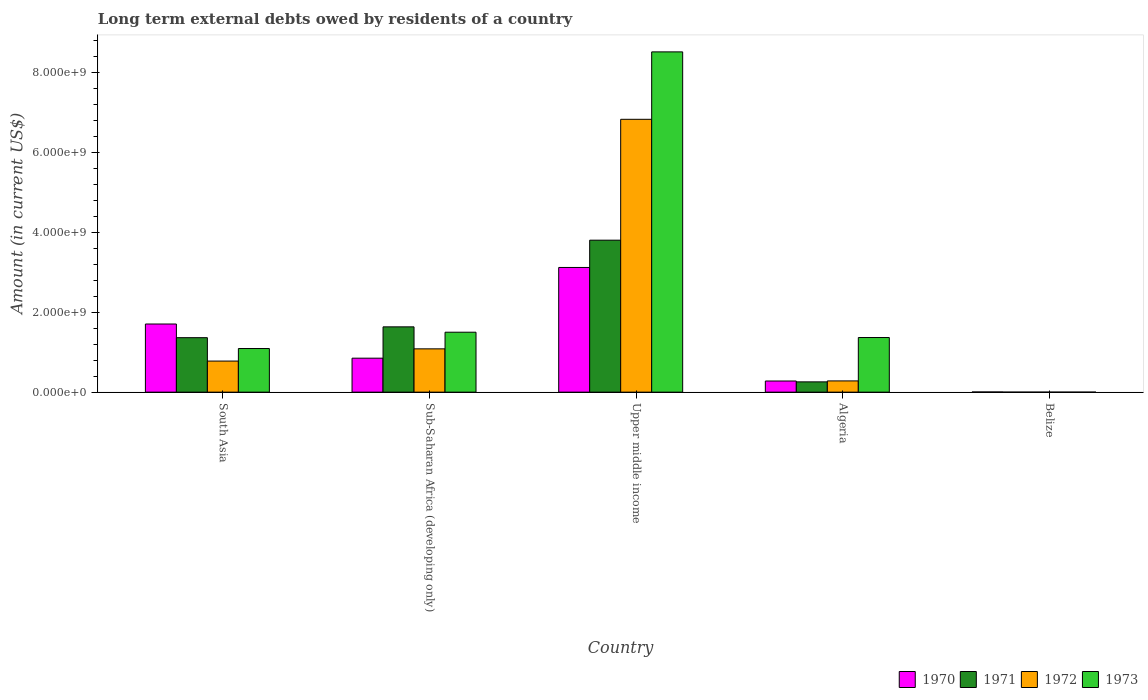How many different coloured bars are there?
Your response must be concise. 4. Are the number of bars per tick equal to the number of legend labels?
Your response must be concise. No. Are the number of bars on each tick of the X-axis equal?
Provide a succinct answer. No. How many bars are there on the 2nd tick from the left?
Your answer should be compact. 4. How many bars are there on the 5th tick from the right?
Provide a short and direct response. 4. What is the label of the 5th group of bars from the left?
Provide a succinct answer. Belize. In how many cases, is the number of bars for a given country not equal to the number of legend labels?
Your response must be concise. 1. What is the amount of long-term external debts owed by residents in 1970 in Upper middle income?
Offer a very short reply. 3.12e+09. Across all countries, what is the maximum amount of long-term external debts owed by residents in 1970?
Offer a very short reply. 3.12e+09. Across all countries, what is the minimum amount of long-term external debts owed by residents in 1970?
Offer a very short reply. 4.30e+06. In which country was the amount of long-term external debts owed by residents in 1970 maximum?
Your answer should be compact. Upper middle income. What is the total amount of long-term external debts owed by residents in 1970 in the graph?
Your answer should be compact. 5.96e+09. What is the difference between the amount of long-term external debts owed by residents in 1970 in Belize and that in South Asia?
Your response must be concise. -1.70e+09. What is the difference between the amount of long-term external debts owed by residents in 1973 in Upper middle income and the amount of long-term external debts owed by residents in 1971 in Algeria?
Provide a short and direct response. 8.25e+09. What is the average amount of long-term external debts owed by residents in 1970 per country?
Offer a very short reply. 1.19e+09. What is the difference between the amount of long-term external debts owed by residents of/in 1973 and amount of long-term external debts owed by residents of/in 1970 in South Asia?
Provide a succinct answer. -6.13e+08. What is the ratio of the amount of long-term external debts owed by residents in 1971 in Algeria to that in South Asia?
Offer a terse response. 0.19. Is the amount of long-term external debts owed by residents in 1970 in Belize less than that in South Asia?
Give a very brief answer. Yes. What is the difference between the highest and the second highest amount of long-term external debts owed by residents in 1970?
Make the answer very short. 1.41e+09. What is the difference between the highest and the lowest amount of long-term external debts owed by residents in 1970?
Your answer should be very brief. 3.11e+09. Is the sum of the amount of long-term external debts owed by residents in 1973 in South Asia and Sub-Saharan Africa (developing only) greater than the maximum amount of long-term external debts owed by residents in 1970 across all countries?
Give a very brief answer. No. Is it the case that in every country, the sum of the amount of long-term external debts owed by residents in 1971 and amount of long-term external debts owed by residents in 1970 is greater than the sum of amount of long-term external debts owed by residents in 1973 and amount of long-term external debts owed by residents in 1972?
Provide a short and direct response. No. Are all the bars in the graph horizontal?
Offer a very short reply. No. How many countries are there in the graph?
Offer a terse response. 5. Are the values on the major ticks of Y-axis written in scientific E-notation?
Make the answer very short. Yes. Where does the legend appear in the graph?
Make the answer very short. Bottom right. What is the title of the graph?
Ensure brevity in your answer.  Long term external debts owed by residents of a country. What is the Amount (in current US$) of 1970 in South Asia?
Make the answer very short. 1.70e+09. What is the Amount (in current US$) of 1971 in South Asia?
Offer a terse response. 1.36e+09. What is the Amount (in current US$) in 1972 in South Asia?
Your response must be concise. 7.77e+08. What is the Amount (in current US$) in 1973 in South Asia?
Ensure brevity in your answer.  1.09e+09. What is the Amount (in current US$) of 1970 in Sub-Saharan Africa (developing only)?
Ensure brevity in your answer.  8.50e+08. What is the Amount (in current US$) of 1971 in Sub-Saharan Africa (developing only)?
Make the answer very short. 1.63e+09. What is the Amount (in current US$) of 1972 in Sub-Saharan Africa (developing only)?
Keep it short and to the point. 1.08e+09. What is the Amount (in current US$) of 1973 in Sub-Saharan Africa (developing only)?
Provide a succinct answer. 1.50e+09. What is the Amount (in current US$) in 1970 in Upper middle income?
Your answer should be very brief. 3.12e+09. What is the Amount (in current US$) in 1971 in Upper middle income?
Ensure brevity in your answer.  3.80e+09. What is the Amount (in current US$) in 1972 in Upper middle income?
Ensure brevity in your answer.  6.82e+09. What is the Amount (in current US$) of 1973 in Upper middle income?
Your response must be concise. 8.51e+09. What is the Amount (in current US$) of 1970 in Algeria?
Provide a succinct answer. 2.79e+08. What is the Amount (in current US$) of 1971 in Algeria?
Your response must be concise. 2.57e+08. What is the Amount (in current US$) in 1972 in Algeria?
Your response must be concise. 2.81e+08. What is the Amount (in current US$) of 1973 in Algeria?
Your answer should be very brief. 1.37e+09. What is the Amount (in current US$) in 1970 in Belize?
Ensure brevity in your answer.  4.30e+06. What is the Amount (in current US$) in 1971 in Belize?
Provide a short and direct response. 0. What is the Amount (in current US$) in 1972 in Belize?
Offer a very short reply. 0. Across all countries, what is the maximum Amount (in current US$) in 1970?
Offer a very short reply. 3.12e+09. Across all countries, what is the maximum Amount (in current US$) in 1971?
Keep it short and to the point. 3.80e+09. Across all countries, what is the maximum Amount (in current US$) of 1972?
Ensure brevity in your answer.  6.82e+09. Across all countries, what is the maximum Amount (in current US$) in 1973?
Your answer should be compact. 8.51e+09. Across all countries, what is the minimum Amount (in current US$) of 1970?
Offer a very short reply. 4.30e+06. Across all countries, what is the minimum Amount (in current US$) in 1971?
Provide a succinct answer. 0. Across all countries, what is the minimum Amount (in current US$) of 1972?
Ensure brevity in your answer.  0. What is the total Amount (in current US$) in 1970 in the graph?
Ensure brevity in your answer.  5.96e+09. What is the total Amount (in current US$) of 1971 in the graph?
Provide a succinct answer. 7.05e+09. What is the total Amount (in current US$) in 1972 in the graph?
Your answer should be very brief. 8.97e+09. What is the total Amount (in current US$) of 1973 in the graph?
Provide a succinct answer. 1.25e+1. What is the difference between the Amount (in current US$) of 1970 in South Asia and that in Sub-Saharan Africa (developing only)?
Keep it short and to the point. 8.55e+08. What is the difference between the Amount (in current US$) in 1971 in South Asia and that in Sub-Saharan Africa (developing only)?
Offer a very short reply. -2.71e+08. What is the difference between the Amount (in current US$) of 1972 in South Asia and that in Sub-Saharan Africa (developing only)?
Offer a very short reply. -3.06e+08. What is the difference between the Amount (in current US$) of 1973 in South Asia and that in Sub-Saharan Africa (developing only)?
Your answer should be very brief. -4.08e+08. What is the difference between the Amount (in current US$) of 1970 in South Asia and that in Upper middle income?
Your answer should be very brief. -1.41e+09. What is the difference between the Amount (in current US$) of 1971 in South Asia and that in Upper middle income?
Offer a very short reply. -2.44e+09. What is the difference between the Amount (in current US$) in 1972 in South Asia and that in Upper middle income?
Ensure brevity in your answer.  -6.05e+09. What is the difference between the Amount (in current US$) of 1973 in South Asia and that in Upper middle income?
Provide a short and direct response. -7.42e+09. What is the difference between the Amount (in current US$) of 1970 in South Asia and that in Algeria?
Your answer should be very brief. 1.43e+09. What is the difference between the Amount (in current US$) of 1971 in South Asia and that in Algeria?
Provide a short and direct response. 1.11e+09. What is the difference between the Amount (in current US$) in 1972 in South Asia and that in Algeria?
Make the answer very short. 4.96e+08. What is the difference between the Amount (in current US$) in 1973 in South Asia and that in Algeria?
Ensure brevity in your answer.  -2.75e+08. What is the difference between the Amount (in current US$) in 1970 in South Asia and that in Belize?
Make the answer very short. 1.70e+09. What is the difference between the Amount (in current US$) of 1970 in Sub-Saharan Africa (developing only) and that in Upper middle income?
Provide a succinct answer. -2.27e+09. What is the difference between the Amount (in current US$) in 1971 in Sub-Saharan Africa (developing only) and that in Upper middle income?
Give a very brief answer. -2.17e+09. What is the difference between the Amount (in current US$) of 1972 in Sub-Saharan Africa (developing only) and that in Upper middle income?
Your answer should be compact. -5.74e+09. What is the difference between the Amount (in current US$) in 1973 in Sub-Saharan Africa (developing only) and that in Upper middle income?
Offer a terse response. -7.01e+09. What is the difference between the Amount (in current US$) in 1970 in Sub-Saharan Africa (developing only) and that in Algeria?
Keep it short and to the point. 5.71e+08. What is the difference between the Amount (in current US$) of 1971 in Sub-Saharan Africa (developing only) and that in Algeria?
Offer a very short reply. 1.38e+09. What is the difference between the Amount (in current US$) of 1972 in Sub-Saharan Africa (developing only) and that in Algeria?
Make the answer very short. 8.02e+08. What is the difference between the Amount (in current US$) of 1973 in Sub-Saharan Africa (developing only) and that in Algeria?
Ensure brevity in your answer.  1.33e+08. What is the difference between the Amount (in current US$) of 1970 in Sub-Saharan Africa (developing only) and that in Belize?
Provide a short and direct response. 8.45e+08. What is the difference between the Amount (in current US$) in 1970 in Upper middle income and that in Algeria?
Make the answer very short. 2.84e+09. What is the difference between the Amount (in current US$) of 1971 in Upper middle income and that in Algeria?
Ensure brevity in your answer.  3.54e+09. What is the difference between the Amount (in current US$) in 1972 in Upper middle income and that in Algeria?
Offer a terse response. 6.54e+09. What is the difference between the Amount (in current US$) in 1973 in Upper middle income and that in Algeria?
Ensure brevity in your answer.  7.14e+09. What is the difference between the Amount (in current US$) in 1970 in Upper middle income and that in Belize?
Make the answer very short. 3.11e+09. What is the difference between the Amount (in current US$) of 1970 in Algeria and that in Belize?
Ensure brevity in your answer.  2.74e+08. What is the difference between the Amount (in current US$) in 1970 in South Asia and the Amount (in current US$) in 1971 in Sub-Saharan Africa (developing only)?
Provide a short and direct response. 7.12e+07. What is the difference between the Amount (in current US$) of 1970 in South Asia and the Amount (in current US$) of 1972 in Sub-Saharan Africa (developing only)?
Provide a succinct answer. 6.21e+08. What is the difference between the Amount (in current US$) of 1970 in South Asia and the Amount (in current US$) of 1973 in Sub-Saharan Africa (developing only)?
Your answer should be very brief. 2.05e+08. What is the difference between the Amount (in current US$) in 1971 in South Asia and the Amount (in current US$) in 1972 in Sub-Saharan Africa (developing only)?
Keep it short and to the point. 2.80e+08. What is the difference between the Amount (in current US$) of 1971 in South Asia and the Amount (in current US$) of 1973 in Sub-Saharan Africa (developing only)?
Keep it short and to the point. -1.37e+08. What is the difference between the Amount (in current US$) of 1972 in South Asia and the Amount (in current US$) of 1973 in Sub-Saharan Africa (developing only)?
Provide a short and direct response. -7.22e+08. What is the difference between the Amount (in current US$) in 1970 in South Asia and the Amount (in current US$) in 1971 in Upper middle income?
Provide a short and direct response. -2.10e+09. What is the difference between the Amount (in current US$) in 1970 in South Asia and the Amount (in current US$) in 1972 in Upper middle income?
Offer a very short reply. -5.12e+09. What is the difference between the Amount (in current US$) of 1970 in South Asia and the Amount (in current US$) of 1973 in Upper middle income?
Your answer should be very brief. -6.81e+09. What is the difference between the Amount (in current US$) in 1971 in South Asia and the Amount (in current US$) in 1972 in Upper middle income?
Offer a terse response. -5.46e+09. What is the difference between the Amount (in current US$) in 1971 in South Asia and the Amount (in current US$) in 1973 in Upper middle income?
Your answer should be compact. -7.15e+09. What is the difference between the Amount (in current US$) in 1972 in South Asia and the Amount (in current US$) in 1973 in Upper middle income?
Offer a very short reply. -7.73e+09. What is the difference between the Amount (in current US$) in 1970 in South Asia and the Amount (in current US$) in 1971 in Algeria?
Your answer should be compact. 1.45e+09. What is the difference between the Amount (in current US$) of 1970 in South Asia and the Amount (in current US$) of 1972 in Algeria?
Offer a very short reply. 1.42e+09. What is the difference between the Amount (in current US$) of 1970 in South Asia and the Amount (in current US$) of 1973 in Algeria?
Ensure brevity in your answer.  3.38e+08. What is the difference between the Amount (in current US$) of 1971 in South Asia and the Amount (in current US$) of 1972 in Algeria?
Provide a succinct answer. 1.08e+09. What is the difference between the Amount (in current US$) of 1971 in South Asia and the Amount (in current US$) of 1973 in Algeria?
Your response must be concise. -3.79e+06. What is the difference between the Amount (in current US$) in 1972 in South Asia and the Amount (in current US$) in 1973 in Algeria?
Your answer should be compact. -5.89e+08. What is the difference between the Amount (in current US$) of 1970 in Sub-Saharan Africa (developing only) and the Amount (in current US$) of 1971 in Upper middle income?
Offer a terse response. -2.95e+09. What is the difference between the Amount (in current US$) of 1970 in Sub-Saharan Africa (developing only) and the Amount (in current US$) of 1972 in Upper middle income?
Keep it short and to the point. -5.97e+09. What is the difference between the Amount (in current US$) in 1970 in Sub-Saharan Africa (developing only) and the Amount (in current US$) in 1973 in Upper middle income?
Make the answer very short. -7.66e+09. What is the difference between the Amount (in current US$) of 1971 in Sub-Saharan Africa (developing only) and the Amount (in current US$) of 1972 in Upper middle income?
Your response must be concise. -5.19e+09. What is the difference between the Amount (in current US$) of 1971 in Sub-Saharan Africa (developing only) and the Amount (in current US$) of 1973 in Upper middle income?
Your response must be concise. -6.88e+09. What is the difference between the Amount (in current US$) in 1972 in Sub-Saharan Africa (developing only) and the Amount (in current US$) in 1973 in Upper middle income?
Give a very brief answer. -7.43e+09. What is the difference between the Amount (in current US$) in 1970 in Sub-Saharan Africa (developing only) and the Amount (in current US$) in 1971 in Algeria?
Provide a short and direct response. 5.93e+08. What is the difference between the Amount (in current US$) in 1970 in Sub-Saharan Africa (developing only) and the Amount (in current US$) in 1972 in Algeria?
Offer a very short reply. 5.69e+08. What is the difference between the Amount (in current US$) of 1970 in Sub-Saharan Africa (developing only) and the Amount (in current US$) of 1973 in Algeria?
Make the answer very short. -5.17e+08. What is the difference between the Amount (in current US$) in 1971 in Sub-Saharan Africa (developing only) and the Amount (in current US$) in 1972 in Algeria?
Your answer should be compact. 1.35e+09. What is the difference between the Amount (in current US$) in 1971 in Sub-Saharan Africa (developing only) and the Amount (in current US$) in 1973 in Algeria?
Offer a terse response. 2.67e+08. What is the difference between the Amount (in current US$) of 1972 in Sub-Saharan Africa (developing only) and the Amount (in current US$) of 1973 in Algeria?
Provide a short and direct response. -2.83e+08. What is the difference between the Amount (in current US$) in 1970 in Upper middle income and the Amount (in current US$) in 1971 in Algeria?
Your response must be concise. 2.86e+09. What is the difference between the Amount (in current US$) in 1970 in Upper middle income and the Amount (in current US$) in 1972 in Algeria?
Offer a terse response. 2.84e+09. What is the difference between the Amount (in current US$) of 1970 in Upper middle income and the Amount (in current US$) of 1973 in Algeria?
Give a very brief answer. 1.75e+09. What is the difference between the Amount (in current US$) of 1971 in Upper middle income and the Amount (in current US$) of 1972 in Algeria?
Offer a terse response. 3.52e+09. What is the difference between the Amount (in current US$) of 1971 in Upper middle income and the Amount (in current US$) of 1973 in Algeria?
Ensure brevity in your answer.  2.43e+09. What is the difference between the Amount (in current US$) of 1972 in Upper middle income and the Amount (in current US$) of 1973 in Algeria?
Offer a very short reply. 5.46e+09. What is the average Amount (in current US$) of 1970 per country?
Provide a short and direct response. 1.19e+09. What is the average Amount (in current US$) of 1971 per country?
Your answer should be very brief. 1.41e+09. What is the average Amount (in current US$) of 1972 per country?
Ensure brevity in your answer.  1.79e+09. What is the average Amount (in current US$) of 1973 per country?
Offer a terse response. 2.49e+09. What is the difference between the Amount (in current US$) of 1970 and Amount (in current US$) of 1971 in South Asia?
Give a very brief answer. 3.42e+08. What is the difference between the Amount (in current US$) of 1970 and Amount (in current US$) of 1972 in South Asia?
Your answer should be compact. 9.27e+08. What is the difference between the Amount (in current US$) in 1970 and Amount (in current US$) in 1973 in South Asia?
Offer a very short reply. 6.13e+08. What is the difference between the Amount (in current US$) in 1971 and Amount (in current US$) in 1972 in South Asia?
Offer a terse response. 5.85e+08. What is the difference between the Amount (in current US$) in 1971 and Amount (in current US$) in 1973 in South Asia?
Provide a short and direct response. 2.72e+08. What is the difference between the Amount (in current US$) in 1972 and Amount (in current US$) in 1973 in South Asia?
Provide a short and direct response. -3.14e+08. What is the difference between the Amount (in current US$) of 1970 and Amount (in current US$) of 1971 in Sub-Saharan Africa (developing only)?
Your answer should be very brief. -7.84e+08. What is the difference between the Amount (in current US$) in 1970 and Amount (in current US$) in 1972 in Sub-Saharan Africa (developing only)?
Your response must be concise. -2.33e+08. What is the difference between the Amount (in current US$) of 1970 and Amount (in current US$) of 1973 in Sub-Saharan Africa (developing only)?
Ensure brevity in your answer.  -6.50e+08. What is the difference between the Amount (in current US$) in 1971 and Amount (in current US$) in 1972 in Sub-Saharan Africa (developing only)?
Offer a very short reply. 5.50e+08. What is the difference between the Amount (in current US$) in 1971 and Amount (in current US$) in 1973 in Sub-Saharan Africa (developing only)?
Your answer should be very brief. 1.34e+08. What is the difference between the Amount (in current US$) in 1972 and Amount (in current US$) in 1973 in Sub-Saharan Africa (developing only)?
Provide a short and direct response. -4.16e+08. What is the difference between the Amount (in current US$) in 1970 and Amount (in current US$) in 1971 in Upper middle income?
Give a very brief answer. -6.83e+08. What is the difference between the Amount (in current US$) in 1970 and Amount (in current US$) in 1972 in Upper middle income?
Provide a succinct answer. -3.71e+09. What is the difference between the Amount (in current US$) in 1970 and Amount (in current US$) in 1973 in Upper middle income?
Keep it short and to the point. -5.39e+09. What is the difference between the Amount (in current US$) of 1971 and Amount (in current US$) of 1972 in Upper middle income?
Provide a short and direct response. -3.02e+09. What is the difference between the Amount (in current US$) of 1971 and Amount (in current US$) of 1973 in Upper middle income?
Ensure brevity in your answer.  -4.71e+09. What is the difference between the Amount (in current US$) of 1972 and Amount (in current US$) of 1973 in Upper middle income?
Ensure brevity in your answer.  -1.69e+09. What is the difference between the Amount (in current US$) in 1970 and Amount (in current US$) in 1971 in Algeria?
Ensure brevity in your answer.  2.18e+07. What is the difference between the Amount (in current US$) in 1970 and Amount (in current US$) in 1972 in Algeria?
Provide a short and direct response. -2.27e+06. What is the difference between the Amount (in current US$) in 1970 and Amount (in current US$) in 1973 in Algeria?
Provide a succinct answer. -1.09e+09. What is the difference between the Amount (in current US$) of 1971 and Amount (in current US$) of 1972 in Algeria?
Offer a terse response. -2.41e+07. What is the difference between the Amount (in current US$) in 1971 and Amount (in current US$) in 1973 in Algeria?
Offer a very short reply. -1.11e+09. What is the difference between the Amount (in current US$) in 1972 and Amount (in current US$) in 1973 in Algeria?
Offer a very short reply. -1.09e+09. What is the ratio of the Amount (in current US$) in 1970 in South Asia to that in Sub-Saharan Africa (developing only)?
Make the answer very short. 2.01. What is the ratio of the Amount (in current US$) in 1971 in South Asia to that in Sub-Saharan Africa (developing only)?
Give a very brief answer. 0.83. What is the ratio of the Amount (in current US$) of 1972 in South Asia to that in Sub-Saharan Africa (developing only)?
Keep it short and to the point. 0.72. What is the ratio of the Amount (in current US$) of 1973 in South Asia to that in Sub-Saharan Africa (developing only)?
Your answer should be compact. 0.73. What is the ratio of the Amount (in current US$) in 1970 in South Asia to that in Upper middle income?
Offer a very short reply. 0.55. What is the ratio of the Amount (in current US$) of 1971 in South Asia to that in Upper middle income?
Give a very brief answer. 0.36. What is the ratio of the Amount (in current US$) of 1972 in South Asia to that in Upper middle income?
Keep it short and to the point. 0.11. What is the ratio of the Amount (in current US$) in 1973 in South Asia to that in Upper middle income?
Offer a terse response. 0.13. What is the ratio of the Amount (in current US$) of 1970 in South Asia to that in Algeria?
Offer a very short reply. 6.11. What is the ratio of the Amount (in current US$) of 1971 in South Asia to that in Algeria?
Offer a very short reply. 5.3. What is the ratio of the Amount (in current US$) of 1972 in South Asia to that in Algeria?
Keep it short and to the point. 2.77. What is the ratio of the Amount (in current US$) in 1973 in South Asia to that in Algeria?
Your response must be concise. 0.8. What is the ratio of the Amount (in current US$) in 1970 in South Asia to that in Belize?
Keep it short and to the point. 396.27. What is the ratio of the Amount (in current US$) of 1970 in Sub-Saharan Africa (developing only) to that in Upper middle income?
Make the answer very short. 0.27. What is the ratio of the Amount (in current US$) of 1971 in Sub-Saharan Africa (developing only) to that in Upper middle income?
Provide a succinct answer. 0.43. What is the ratio of the Amount (in current US$) in 1972 in Sub-Saharan Africa (developing only) to that in Upper middle income?
Offer a terse response. 0.16. What is the ratio of the Amount (in current US$) of 1973 in Sub-Saharan Africa (developing only) to that in Upper middle income?
Offer a very short reply. 0.18. What is the ratio of the Amount (in current US$) in 1970 in Sub-Saharan Africa (developing only) to that in Algeria?
Give a very brief answer. 3.05. What is the ratio of the Amount (in current US$) of 1971 in Sub-Saharan Africa (developing only) to that in Algeria?
Keep it short and to the point. 6.35. What is the ratio of the Amount (in current US$) of 1972 in Sub-Saharan Africa (developing only) to that in Algeria?
Offer a terse response. 3.85. What is the ratio of the Amount (in current US$) in 1973 in Sub-Saharan Africa (developing only) to that in Algeria?
Offer a very short reply. 1.1. What is the ratio of the Amount (in current US$) in 1970 in Sub-Saharan Africa (developing only) to that in Belize?
Your response must be concise. 197.54. What is the ratio of the Amount (in current US$) in 1970 in Upper middle income to that in Algeria?
Offer a terse response. 11.19. What is the ratio of the Amount (in current US$) of 1971 in Upper middle income to that in Algeria?
Keep it short and to the point. 14.79. What is the ratio of the Amount (in current US$) in 1972 in Upper middle income to that in Algeria?
Your answer should be very brief. 24.28. What is the ratio of the Amount (in current US$) of 1973 in Upper middle income to that in Algeria?
Give a very brief answer. 6.23. What is the ratio of the Amount (in current US$) of 1970 in Upper middle income to that in Belize?
Your answer should be very brief. 725.1. What is the ratio of the Amount (in current US$) in 1970 in Algeria to that in Belize?
Give a very brief answer. 64.82. What is the difference between the highest and the second highest Amount (in current US$) of 1970?
Ensure brevity in your answer.  1.41e+09. What is the difference between the highest and the second highest Amount (in current US$) of 1971?
Your answer should be compact. 2.17e+09. What is the difference between the highest and the second highest Amount (in current US$) of 1972?
Make the answer very short. 5.74e+09. What is the difference between the highest and the second highest Amount (in current US$) in 1973?
Offer a very short reply. 7.01e+09. What is the difference between the highest and the lowest Amount (in current US$) in 1970?
Your answer should be compact. 3.11e+09. What is the difference between the highest and the lowest Amount (in current US$) of 1971?
Offer a terse response. 3.80e+09. What is the difference between the highest and the lowest Amount (in current US$) of 1972?
Your response must be concise. 6.82e+09. What is the difference between the highest and the lowest Amount (in current US$) of 1973?
Your response must be concise. 8.51e+09. 